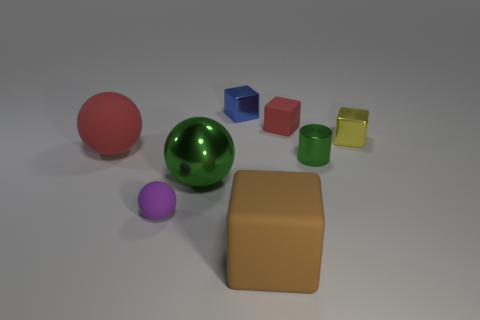Subtract all big rubber spheres. How many spheres are left? 2 Add 1 brown matte things. How many objects exist? 9 Subtract 2 spheres. How many spheres are left? 1 Subtract all green balls. How many balls are left? 2 Subtract 0 yellow cylinders. How many objects are left? 8 Subtract all spheres. How many objects are left? 5 Subtract all green balls. Subtract all purple blocks. How many balls are left? 2 Subtract all green cubes. How many red spheres are left? 1 Subtract all small red matte blocks. Subtract all yellow matte cylinders. How many objects are left? 7 Add 2 purple matte balls. How many purple matte balls are left? 3 